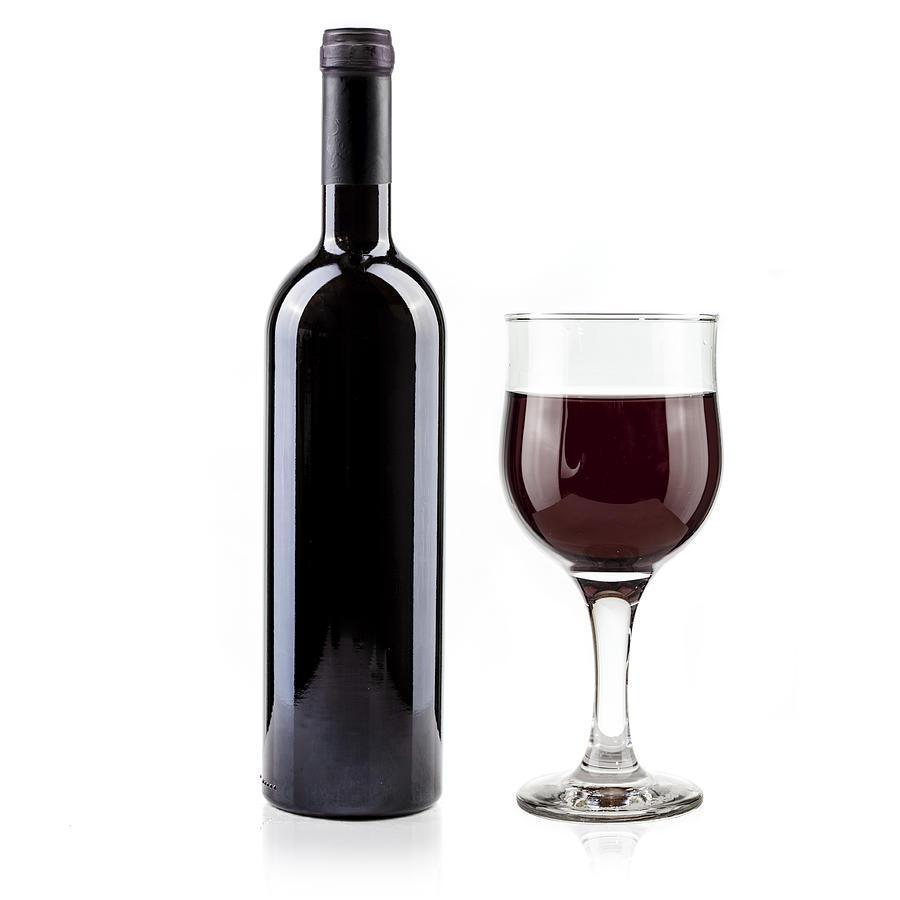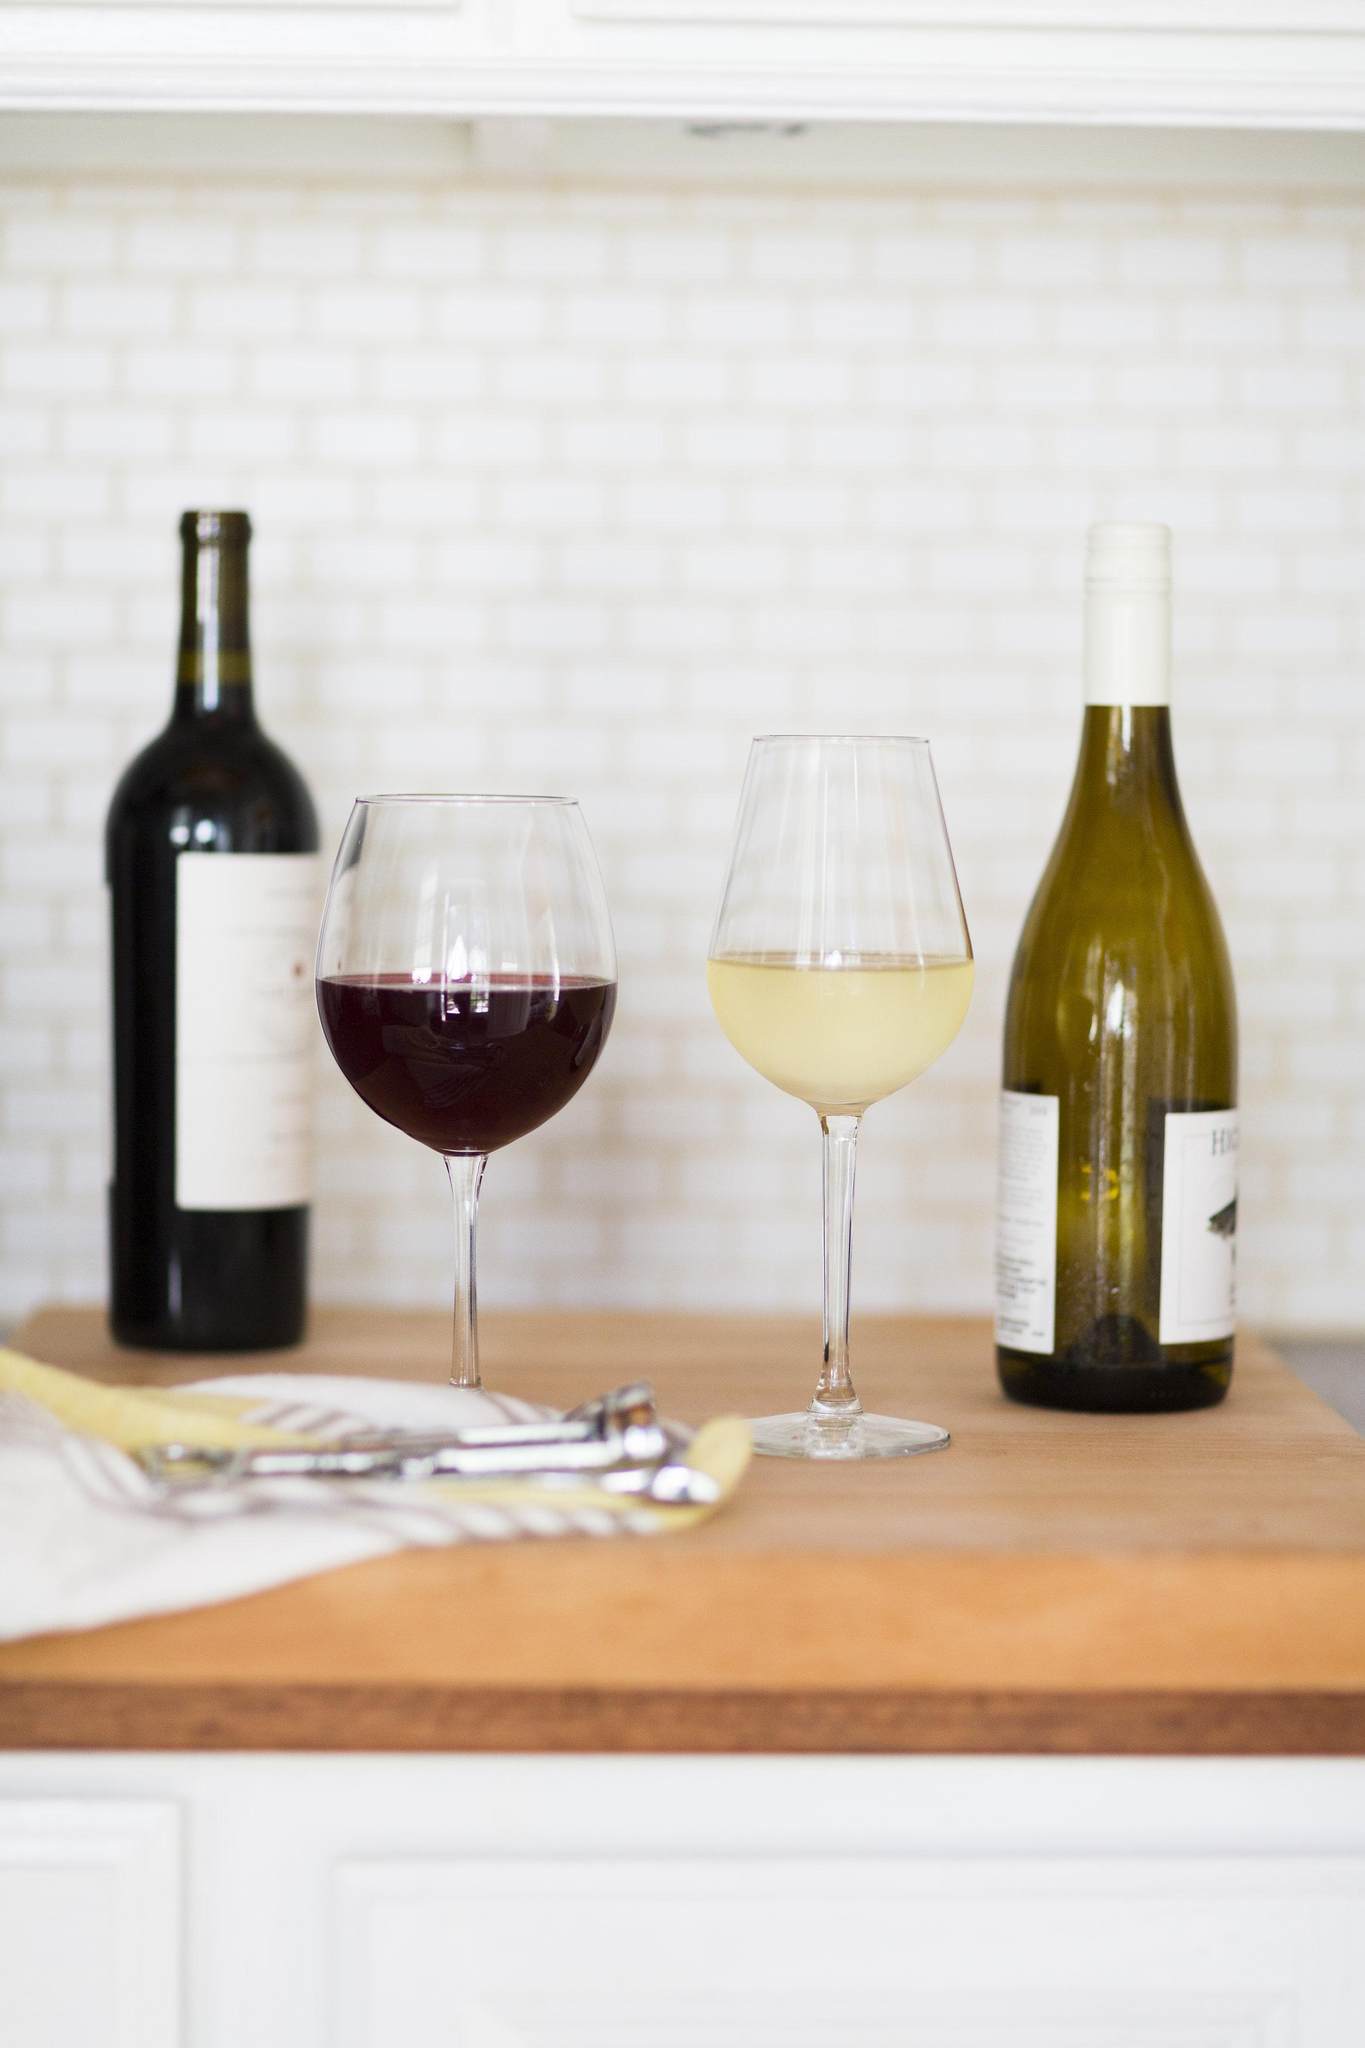The first image is the image on the left, the second image is the image on the right. For the images displayed, is the sentence "There is one wine bottle in the left image." factually correct? Answer yes or no. Yes. The first image is the image on the left, the second image is the image on the right. Assess this claim about the two images: "Exactly one bottle of wine is standing in one image.". Correct or not? Answer yes or no. Yes. 